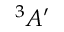<formula> <loc_0><loc_0><loc_500><loc_500>^ { 3 } A ^ { \prime }</formula> 